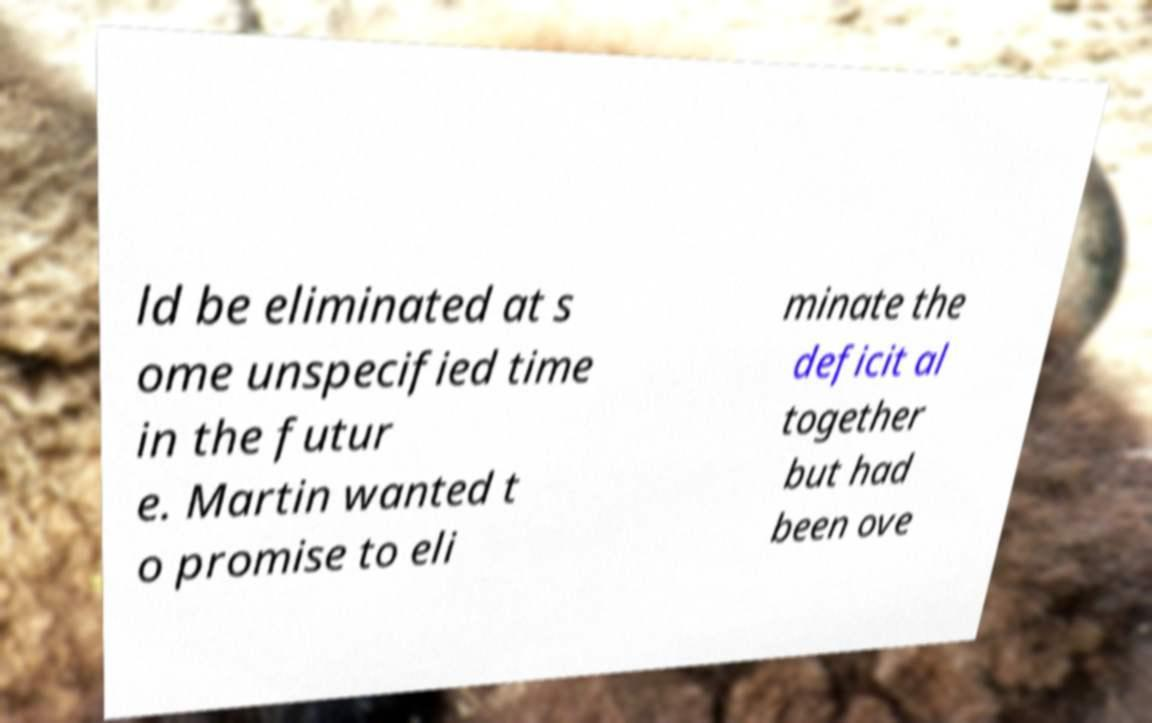Could you assist in decoding the text presented in this image and type it out clearly? ld be eliminated at s ome unspecified time in the futur e. Martin wanted t o promise to eli minate the deficit al together but had been ove 